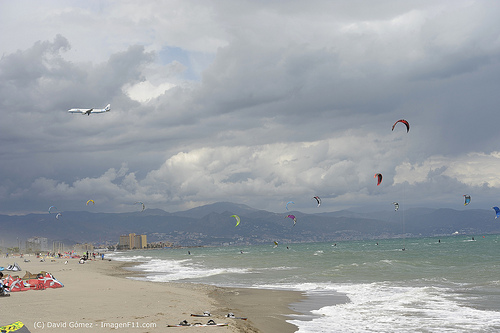Please provide a short description of the skyline in the background. The skyline in the background is framed by majestic mountains, partially shrouded in clouds, giving a sense of elevation and grandeur. The mountains form a natural barrier and create a picturesque backdrop to the dynamic beach scene in the foreground. What kind of weather can you infer from the image? The weather appears to be overcast with clouds dominating the sky, but there is no sign of rain. It seems like a breezy day, which is ideal for flying kites and enjoying the beach without the harshness of direct sunlight. 